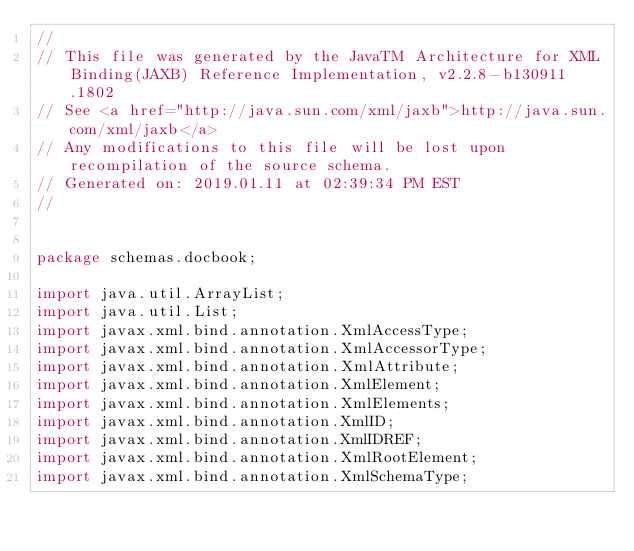<code> <loc_0><loc_0><loc_500><loc_500><_Java_>//
// This file was generated by the JavaTM Architecture for XML Binding(JAXB) Reference Implementation, v2.2.8-b130911.1802 
// See <a href="http://java.sun.com/xml/jaxb">http://java.sun.com/xml/jaxb</a> 
// Any modifications to this file will be lost upon recompilation of the source schema. 
// Generated on: 2019.01.11 at 02:39:34 PM EST 
//


package schemas.docbook;

import java.util.ArrayList;
import java.util.List;
import javax.xml.bind.annotation.XmlAccessType;
import javax.xml.bind.annotation.XmlAccessorType;
import javax.xml.bind.annotation.XmlAttribute;
import javax.xml.bind.annotation.XmlElement;
import javax.xml.bind.annotation.XmlElements;
import javax.xml.bind.annotation.XmlID;
import javax.xml.bind.annotation.XmlIDREF;
import javax.xml.bind.annotation.XmlRootElement;
import javax.xml.bind.annotation.XmlSchemaType;</code> 